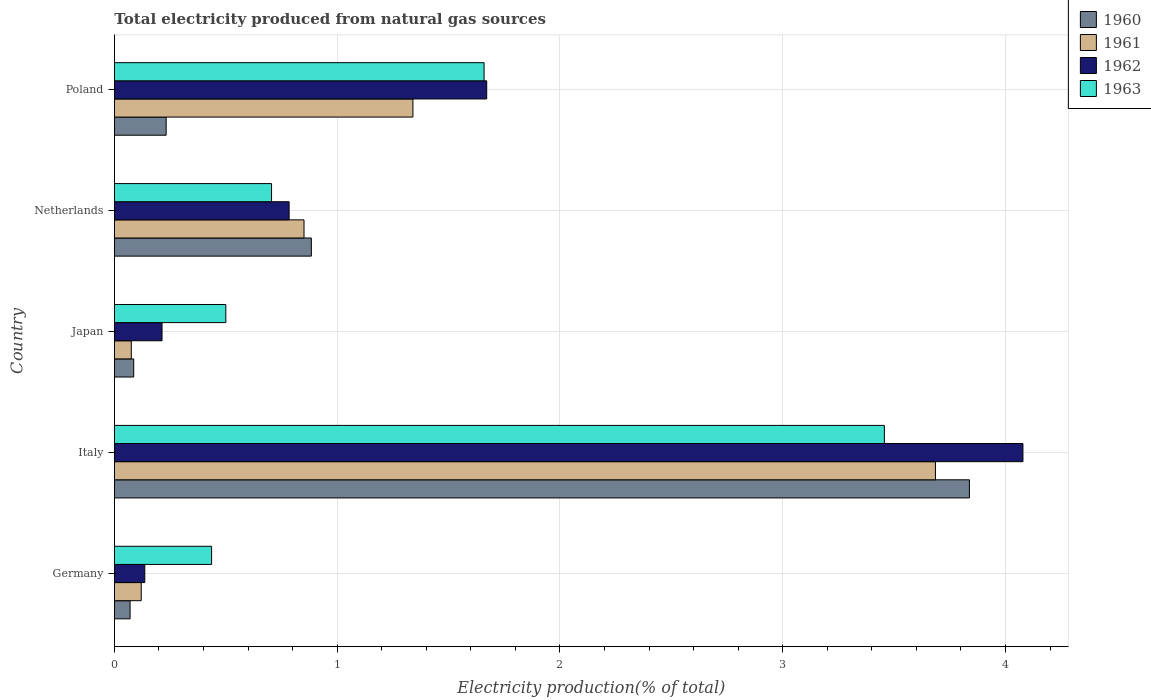How many different coloured bars are there?
Offer a very short reply. 4. Are the number of bars on each tick of the Y-axis equal?
Keep it short and to the point. Yes. How many bars are there on the 2nd tick from the bottom?
Offer a very short reply. 4. What is the label of the 2nd group of bars from the top?
Give a very brief answer. Netherlands. What is the total electricity produced in 1961 in Germany?
Your response must be concise. 0.12. Across all countries, what is the maximum total electricity produced in 1961?
Offer a very short reply. 3.69. Across all countries, what is the minimum total electricity produced in 1961?
Keep it short and to the point. 0.08. What is the total total electricity produced in 1962 in the graph?
Offer a very short reply. 6.88. What is the difference between the total electricity produced in 1960 in Germany and that in Italy?
Your answer should be very brief. -3.77. What is the difference between the total electricity produced in 1961 in Japan and the total electricity produced in 1963 in Germany?
Your answer should be very brief. -0.36. What is the average total electricity produced in 1960 per country?
Provide a short and direct response. 1.02. What is the difference between the total electricity produced in 1961 and total electricity produced in 1963 in Italy?
Your response must be concise. 0.23. What is the ratio of the total electricity produced in 1962 in Germany to that in Japan?
Offer a very short reply. 0.64. Is the difference between the total electricity produced in 1961 in Netherlands and Poland greater than the difference between the total electricity produced in 1963 in Netherlands and Poland?
Provide a succinct answer. Yes. What is the difference between the highest and the second highest total electricity produced in 1962?
Give a very brief answer. 2.41. What is the difference between the highest and the lowest total electricity produced in 1961?
Give a very brief answer. 3.61. In how many countries, is the total electricity produced in 1960 greater than the average total electricity produced in 1960 taken over all countries?
Your answer should be compact. 1. Is the sum of the total electricity produced in 1961 in Japan and Netherlands greater than the maximum total electricity produced in 1960 across all countries?
Offer a terse response. No. Is it the case that in every country, the sum of the total electricity produced in 1960 and total electricity produced in 1962 is greater than the sum of total electricity produced in 1961 and total electricity produced in 1963?
Make the answer very short. No. How many countries are there in the graph?
Your answer should be compact. 5. Does the graph contain grids?
Offer a terse response. Yes. How are the legend labels stacked?
Make the answer very short. Vertical. What is the title of the graph?
Provide a short and direct response. Total electricity produced from natural gas sources. Does "1960" appear as one of the legend labels in the graph?
Provide a short and direct response. Yes. What is the label or title of the Y-axis?
Your answer should be compact. Country. What is the Electricity production(% of total) in 1960 in Germany?
Offer a terse response. 0.07. What is the Electricity production(% of total) of 1961 in Germany?
Offer a very short reply. 0.12. What is the Electricity production(% of total) in 1962 in Germany?
Your answer should be compact. 0.14. What is the Electricity production(% of total) in 1963 in Germany?
Provide a succinct answer. 0.44. What is the Electricity production(% of total) of 1960 in Italy?
Your answer should be compact. 3.84. What is the Electricity production(% of total) in 1961 in Italy?
Provide a succinct answer. 3.69. What is the Electricity production(% of total) of 1962 in Italy?
Ensure brevity in your answer.  4.08. What is the Electricity production(% of total) in 1963 in Italy?
Your response must be concise. 3.46. What is the Electricity production(% of total) in 1960 in Japan?
Provide a succinct answer. 0.09. What is the Electricity production(% of total) of 1961 in Japan?
Offer a terse response. 0.08. What is the Electricity production(% of total) of 1962 in Japan?
Make the answer very short. 0.21. What is the Electricity production(% of total) of 1963 in Japan?
Make the answer very short. 0.5. What is the Electricity production(% of total) in 1960 in Netherlands?
Give a very brief answer. 0.88. What is the Electricity production(% of total) in 1961 in Netherlands?
Provide a short and direct response. 0.85. What is the Electricity production(% of total) in 1962 in Netherlands?
Keep it short and to the point. 0.78. What is the Electricity production(% of total) of 1963 in Netherlands?
Make the answer very short. 0.71. What is the Electricity production(% of total) in 1960 in Poland?
Provide a succinct answer. 0.23. What is the Electricity production(% of total) in 1961 in Poland?
Make the answer very short. 1.34. What is the Electricity production(% of total) in 1962 in Poland?
Keep it short and to the point. 1.67. What is the Electricity production(% of total) of 1963 in Poland?
Your answer should be compact. 1.66. Across all countries, what is the maximum Electricity production(% of total) of 1960?
Keep it short and to the point. 3.84. Across all countries, what is the maximum Electricity production(% of total) in 1961?
Provide a short and direct response. 3.69. Across all countries, what is the maximum Electricity production(% of total) of 1962?
Offer a very short reply. 4.08. Across all countries, what is the maximum Electricity production(% of total) of 1963?
Your answer should be very brief. 3.46. Across all countries, what is the minimum Electricity production(% of total) in 1960?
Make the answer very short. 0.07. Across all countries, what is the minimum Electricity production(% of total) of 1961?
Ensure brevity in your answer.  0.08. Across all countries, what is the minimum Electricity production(% of total) in 1962?
Ensure brevity in your answer.  0.14. Across all countries, what is the minimum Electricity production(% of total) of 1963?
Give a very brief answer. 0.44. What is the total Electricity production(% of total) of 1960 in the graph?
Provide a succinct answer. 5.11. What is the total Electricity production(% of total) of 1961 in the graph?
Provide a short and direct response. 6.07. What is the total Electricity production(% of total) of 1962 in the graph?
Your answer should be compact. 6.88. What is the total Electricity production(% of total) of 1963 in the graph?
Your answer should be compact. 6.76. What is the difference between the Electricity production(% of total) of 1960 in Germany and that in Italy?
Offer a terse response. -3.77. What is the difference between the Electricity production(% of total) of 1961 in Germany and that in Italy?
Provide a short and direct response. -3.57. What is the difference between the Electricity production(% of total) in 1962 in Germany and that in Italy?
Keep it short and to the point. -3.94. What is the difference between the Electricity production(% of total) of 1963 in Germany and that in Italy?
Ensure brevity in your answer.  -3.02. What is the difference between the Electricity production(% of total) of 1960 in Germany and that in Japan?
Provide a short and direct response. -0.02. What is the difference between the Electricity production(% of total) of 1961 in Germany and that in Japan?
Make the answer very short. 0.04. What is the difference between the Electricity production(% of total) in 1962 in Germany and that in Japan?
Your answer should be compact. -0.08. What is the difference between the Electricity production(% of total) of 1963 in Germany and that in Japan?
Keep it short and to the point. -0.06. What is the difference between the Electricity production(% of total) in 1960 in Germany and that in Netherlands?
Provide a short and direct response. -0.81. What is the difference between the Electricity production(% of total) in 1961 in Germany and that in Netherlands?
Your answer should be very brief. -0.73. What is the difference between the Electricity production(% of total) of 1962 in Germany and that in Netherlands?
Make the answer very short. -0.65. What is the difference between the Electricity production(% of total) of 1963 in Germany and that in Netherlands?
Offer a terse response. -0.27. What is the difference between the Electricity production(% of total) of 1960 in Germany and that in Poland?
Make the answer very short. -0.16. What is the difference between the Electricity production(% of total) of 1961 in Germany and that in Poland?
Give a very brief answer. -1.22. What is the difference between the Electricity production(% of total) in 1962 in Germany and that in Poland?
Provide a short and direct response. -1.53. What is the difference between the Electricity production(% of total) of 1963 in Germany and that in Poland?
Offer a very short reply. -1.22. What is the difference between the Electricity production(% of total) in 1960 in Italy and that in Japan?
Give a very brief answer. 3.75. What is the difference between the Electricity production(% of total) of 1961 in Italy and that in Japan?
Your answer should be compact. 3.61. What is the difference between the Electricity production(% of total) in 1962 in Italy and that in Japan?
Give a very brief answer. 3.86. What is the difference between the Electricity production(% of total) of 1963 in Italy and that in Japan?
Make the answer very short. 2.96. What is the difference between the Electricity production(% of total) in 1960 in Italy and that in Netherlands?
Offer a terse response. 2.95. What is the difference between the Electricity production(% of total) in 1961 in Italy and that in Netherlands?
Provide a succinct answer. 2.83. What is the difference between the Electricity production(% of total) in 1962 in Italy and that in Netherlands?
Offer a very short reply. 3.29. What is the difference between the Electricity production(% of total) in 1963 in Italy and that in Netherlands?
Keep it short and to the point. 2.75. What is the difference between the Electricity production(% of total) in 1960 in Italy and that in Poland?
Provide a short and direct response. 3.61. What is the difference between the Electricity production(% of total) of 1961 in Italy and that in Poland?
Ensure brevity in your answer.  2.35. What is the difference between the Electricity production(% of total) of 1962 in Italy and that in Poland?
Offer a terse response. 2.41. What is the difference between the Electricity production(% of total) in 1963 in Italy and that in Poland?
Your answer should be compact. 1.8. What is the difference between the Electricity production(% of total) in 1960 in Japan and that in Netherlands?
Your answer should be very brief. -0.8. What is the difference between the Electricity production(% of total) in 1961 in Japan and that in Netherlands?
Keep it short and to the point. -0.78. What is the difference between the Electricity production(% of total) of 1962 in Japan and that in Netherlands?
Offer a terse response. -0.57. What is the difference between the Electricity production(% of total) of 1963 in Japan and that in Netherlands?
Your response must be concise. -0.21. What is the difference between the Electricity production(% of total) in 1960 in Japan and that in Poland?
Your response must be concise. -0.15. What is the difference between the Electricity production(% of total) in 1961 in Japan and that in Poland?
Ensure brevity in your answer.  -1.26. What is the difference between the Electricity production(% of total) in 1962 in Japan and that in Poland?
Offer a very short reply. -1.46. What is the difference between the Electricity production(% of total) of 1963 in Japan and that in Poland?
Provide a short and direct response. -1.16. What is the difference between the Electricity production(% of total) in 1960 in Netherlands and that in Poland?
Make the answer very short. 0.65. What is the difference between the Electricity production(% of total) of 1961 in Netherlands and that in Poland?
Provide a short and direct response. -0.49. What is the difference between the Electricity production(% of total) of 1962 in Netherlands and that in Poland?
Offer a very short reply. -0.89. What is the difference between the Electricity production(% of total) in 1963 in Netherlands and that in Poland?
Provide a short and direct response. -0.95. What is the difference between the Electricity production(% of total) of 1960 in Germany and the Electricity production(% of total) of 1961 in Italy?
Offer a very short reply. -3.62. What is the difference between the Electricity production(% of total) in 1960 in Germany and the Electricity production(% of total) in 1962 in Italy?
Make the answer very short. -4.01. What is the difference between the Electricity production(% of total) of 1960 in Germany and the Electricity production(% of total) of 1963 in Italy?
Provide a succinct answer. -3.39. What is the difference between the Electricity production(% of total) in 1961 in Germany and the Electricity production(% of total) in 1962 in Italy?
Provide a short and direct response. -3.96. What is the difference between the Electricity production(% of total) of 1961 in Germany and the Electricity production(% of total) of 1963 in Italy?
Provide a succinct answer. -3.34. What is the difference between the Electricity production(% of total) of 1962 in Germany and the Electricity production(% of total) of 1963 in Italy?
Ensure brevity in your answer.  -3.32. What is the difference between the Electricity production(% of total) in 1960 in Germany and the Electricity production(% of total) in 1961 in Japan?
Keep it short and to the point. -0.01. What is the difference between the Electricity production(% of total) of 1960 in Germany and the Electricity production(% of total) of 1962 in Japan?
Your answer should be very brief. -0.14. What is the difference between the Electricity production(% of total) of 1960 in Germany and the Electricity production(% of total) of 1963 in Japan?
Offer a very short reply. -0.43. What is the difference between the Electricity production(% of total) of 1961 in Germany and the Electricity production(% of total) of 1962 in Japan?
Provide a short and direct response. -0.09. What is the difference between the Electricity production(% of total) in 1961 in Germany and the Electricity production(% of total) in 1963 in Japan?
Keep it short and to the point. -0.38. What is the difference between the Electricity production(% of total) in 1962 in Germany and the Electricity production(% of total) in 1963 in Japan?
Your answer should be very brief. -0.36. What is the difference between the Electricity production(% of total) of 1960 in Germany and the Electricity production(% of total) of 1961 in Netherlands?
Your answer should be very brief. -0.78. What is the difference between the Electricity production(% of total) of 1960 in Germany and the Electricity production(% of total) of 1962 in Netherlands?
Provide a succinct answer. -0.71. What is the difference between the Electricity production(% of total) of 1960 in Germany and the Electricity production(% of total) of 1963 in Netherlands?
Offer a very short reply. -0.64. What is the difference between the Electricity production(% of total) of 1961 in Germany and the Electricity production(% of total) of 1962 in Netherlands?
Your answer should be very brief. -0.66. What is the difference between the Electricity production(% of total) of 1961 in Germany and the Electricity production(% of total) of 1963 in Netherlands?
Ensure brevity in your answer.  -0.58. What is the difference between the Electricity production(% of total) of 1962 in Germany and the Electricity production(% of total) of 1963 in Netherlands?
Provide a succinct answer. -0.57. What is the difference between the Electricity production(% of total) in 1960 in Germany and the Electricity production(% of total) in 1961 in Poland?
Make the answer very short. -1.27. What is the difference between the Electricity production(% of total) in 1960 in Germany and the Electricity production(% of total) in 1962 in Poland?
Your answer should be compact. -1.6. What is the difference between the Electricity production(% of total) in 1960 in Germany and the Electricity production(% of total) in 1963 in Poland?
Ensure brevity in your answer.  -1.59. What is the difference between the Electricity production(% of total) of 1961 in Germany and the Electricity production(% of total) of 1962 in Poland?
Offer a terse response. -1.55. What is the difference between the Electricity production(% of total) of 1961 in Germany and the Electricity production(% of total) of 1963 in Poland?
Your answer should be very brief. -1.54. What is the difference between the Electricity production(% of total) of 1962 in Germany and the Electricity production(% of total) of 1963 in Poland?
Your response must be concise. -1.52. What is the difference between the Electricity production(% of total) of 1960 in Italy and the Electricity production(% of total) of 1961 in Japan?
Your answer should be very brief. 3.76. What is the difference between the Electricity production(% of total) of 1960 in Italy and the Electricity production(% of total) of 1962 in Japan?
Your response must be concise. 3.62. What is the difference between the Electricity production(% of total) in 1960 in Italy and the Electricity production(% of total) in 1963 in Japan?
Your answer should be very brief. 3.34. What is the difference between the Electricity production(% of total) of 1961 in Italy and the Electricity production(% of total) of 1962 in Japan?
Your answer should be very brief. 3.47. What is the difference between the Electricity production(% of total) of 1961 in Italy and the Electricity production(% of total) of 1963 in Japan?
Offer a terse response. 3.19. What is the difference between the Electricity production(% of total) in 1962 in Italy and the Electricity production(% of total) in 1963 in Japan?
Your answer should be compact. 3.58. What is the difference between the Electricity production(% of total) of 1960 in Italy and the Electricity production(% of total) of 1961 in Netherlands?
Your response must be concise. 2.99. What is the difference between the Electricity production(% of total) in 1960 in Italy and the Electricity production(% of total) in 1962 in Netherlands?
Your response must be concise. 3.05. What is the difference between the Electricity production(% of total) of 1960 in Italy and the Electricity production(% of total) of 1963 in Netherlands?
Your response must be concise. 3.13. What is the difference between the Electricity production(% of total) in 1961 in Italy and the Electricity production(% of total) in 1962 in Netherlands?
Your answer should be compact. 2.9. What is the difference between the Electricity production(% of total) of 1961 in Italy and the Electricity production(% of total) of 1963 in Netherlands?
Provide a succinct answer. 2.98. What is the difference between the Electricity production(% of total) of 1962 in Italy and the Electricity production(% of total) of 1963 in Netherlands?
Give a very brief answer. 3.37. What is the difference between the Electricity production(% of total) in 1960 in Italy and the Electricity production(% of total) in 1961 in Poland?
Your answer should be very brief. 2.5. What is the difference between the Electricity production(% of total) of 1960 in Italy and the Electricity production(% of total) of 1962 in Poland?
Provide a succinct answer. 2.17. What is the difference between the Electricity production(% of total) in 1960 in Italy and the Electricity production(% of total) in 1963 in Poland?
Offer a terse response. 2.18. What is the difference between the Electricity production(% of total) of 1961 in Italy and the Electricity production(% of total) of 1962 in Poland?
Offer a terse response. 2.01. What is the difference between the Electricity production(% of total) in 1961 in Italy and the Electricity production(% of total) in 1963 in Poland?
Offer a terse response. 2.03. What is the difference between the Electricity production(% of total) in 1962 in Italy and the Electricity production(% of total) in 1963 in Poland?
Provide a succinct answer. 2.42. What is the difference between the Electricity production(% of total) of 1960 in Japan and the Electricity production(% of total) of 1961 in Netherlands?
Your response must be concise. -0.76. What is the difference between the Electricity production(% of total) in 1960 in Japan and the Electricity production(% of total) in 1962 in Netherlands?
Make the answer very short. -0.7. What is the difference between the Electricity production(% of total) of 1960 in Japan and the Electricity production(% of total) of 1963 in Netherlands?
Make the answer very short. -0.62. What is the difference between the Electricity production(% of total) of 1961 in Japan and the Electricity production(% of total) of 1962 in Netherlands?
Your answer should be compact. -0.71. What is the difference between the Electricity production(% of total) in 1961 in Japan and the Electricity production(% of total) in 1963 in Netherlands?
Offer a terse response. -0.63. What is the difference between the Electricity production(% of total) in 1962 in Japan and the Electricity production(% of total) in 1963 in Netherlands?
Your answer should be compact. -0.49. What is the difference between the Electricity production(% of total) in 1960 in Japan and the Electricity production(% of total) in 1961 in Poland?
Provide a succinct answer. -1.25. What is the difference between the Electricity production(% of total) in 1960 in Japan and the Electricity production(% of total) in 1962 in Poland?
Ensure brevity in your answer.  -1.58. What is the difference between the Electricity production(% of total) in 1960 in Japan and the Electricity production(% of total) in 1963 in Poland?
Make the answer very short. -1.57. What is the difference between the Electricity production(% of total) in 1961 in Japan and the Electricity production(% of total) in 1962 in Poland?
Make the answer very short. -1.6. What is the difference between the Electricity production(% of total) in 1961 in Japan and the Electricity production(% of total) in 1963 in Poland?
Provide a short and direct response. -1.58. What is the difference between the Electricity production(% of total) in 1962 in Japan and the Electricity production(% of total) in 1963 in Poland?
Offer a terse response. -1.45. What is the difference between the Electricity production(% of total) in 1960 in Netherlands and the Electricity production(% of total) in 1961 in Poland?
Provide a short and direct response. -0.46. What is the difference between the Electricity production(% of total) of 1960 in Netherlands and the Electricity production(% of total) of 1962 in Poland?
Your answer should be compact. -0.79. What is the difference between the Electricity production(% of total) of 1960 in Netherlands and the Electricity production(% of total) of 1963 in Poland?
Offer a terse response. -0.78. What is the difference between the Electricity production(% of total) in 1961 in Netherlands and the Electricity production(% of total) in 1962 in Poland?
Give a very brief answer. -0.82. What is the difference between the Electricity production(% of total) of 1961 in Netherlands and the Electricity production(% of total) of 1963 in Poland?
Make the answer very short. -0.81. What is the difference between the Electricity production(% of total) of 1962 in Netherlands and the Electricity production(% of total) of 1963 in Poland?
Your response must be concise. -0.88. What is the average Electricity production(% of total) in 1960 per country?
Provide a short and direct response. 1.02. What is the average Electricity production(% of total) in 1961 per country?
Provide a short and direct response. 1.21. What is the average Electricity production(% of total) in 1962 per country?
Your answer should be compact. 1.38. What is the average Electricity production(% of total) in 1963 per country?
Make the answer very short. 1.35. What is the difference between the Electricity production(% of total) of 1960 and Electricity production(% of total) of 1961 in Germany?
Give a very brief answer. -0.05. What is the difference between the Electricity production(% of total) in 1960 and Electricity production(% of total) in 1962 in Germany?
Keep it short and to the point. -0.07. What is the difference between the Electricity production(% of total) in 1960 and Electricity production(% of total) in 1963 in Germany?
Provide a succinct answer. -0.37. What is the difference between the Electricity production(% of total) in 1961 and Electricity production(% of total) in 1962 in Germany?
Ensure brevity in your answer.  -0.02. What is the difference between the Electricity production(% of total) of 1961 and Electricity production(% of total) of 1963 in Germany?
Your answer should be very brief. -0.32. What is the difference between the Electricity production(% of total) of 1962 and Electricity production(% of total) of 1963 in Germany?
Offer a terse response. -0.3. What is the difference between the Electricity production(% of total) of 1960 and Electricity production(% of total) of 1961 in Italy?
Your answer should be very brief. 0.15. What is the difference between the Electricity production(% of total) in 1960 and Electricity production(% of total) in 1962 in Italy?
Your answer should be very brief. -0.24. What is the difference between the Electricity production(% of total) in 1960 and Electricity production(% of total) in 1963 in Italy?
Provide a short and direct response. 0.38. What is the difference between the Electricity production(% of total) in 1961 and Electricity production(% of total) in 1962 in Italy?
Your response must be concise. -0.39. What is the difference between the Electricity production(% of total) of 1961 and Electricity production(% of total) of 1963 in Italy?
Ensure brevity in your answer.  0.23. What is the difference between the Electricity production(% of total) in 1962 and Electricity production(% of total) in 1963 in Italy?
Provide a short and direct response. 0.62. What is the difference between the Electricity production(% of total) of 1960 and Electricity production(% of total) of 1961 in Japan?
Make the answer very short. 0.01. What is the difference between the Electricity production(% of total) in 1960 and Electricity production(% of total) in 1962 in Japan?
Keep it short and to the point. -0.13. What is the difference between the Electricity production(% of total) in 1960 and Electricity production(% of total) in 1963 in Japan?
Your answer should be compact. -0.41. What is the difference between the Electricity production(% of total) in 1961 and Electricity production(% of total) in 1962 in Japan?
Provide a succinct answer. -0.14. What is the difference between the Electricity production(% of total) in 1961 and Electricity production(% of total) in 1963 in Japan?
Ensure brevity in your answer.  -0.42. What is the difference between the Electricity production(% of total) in 1962 and Electricity production(% of total) in 1963 in Japan?
Offer a terse response. -0.29. What is the difference between the Electricity production(% of total) in 1960 and Electricity production(% of total) in 1961 in Netherlands?
Give a very brief answer. 0.03. What is the difference between the Electricity production(% of total) in 1960 and Electricity production(% of total) in 1962 in Netherlands?
Provide a succinct answer. 0.1. What is the difference between the Electricity production(% of total) in 1960 and Electricity production(% of total) in 1963 in Netherlands?
Your answer should be compact. 0.18. What is the difference between the Electricity production(% of total) of 1961 and Electricity production(% of total) of 1962 in Netherlands?
Provide a short and direct response. 0.07. What is the difference between the Electricity production(% of total) of 1961 and Electricity production(% of total) of 1963 in Netherlands?
Offer a very short reply. 0.15. What is the difference between the Electricity production(% of total) of 1962 and Electricity production(% of total) of 1963 in Netherlands?
Keep it short and to the point. 0.08. What is the difference between the Electricity production(% of total) of 1960 and Electricity production(% of total) of 1961 in Poland?
Give a very brief answer. -1.11. What is the difference between the Electricity production(% of total) in 1960 and Electricity production(% of total) in 1962 in Poland?
Your answer should be very brief. -1.44. What is the difference between the Electricity production(% of total) of 1960 and Electricity production(% of total) of 1963 in Poland?
Provide a succinct answer. -1.43. What is the difference between the Electricity production(% of total) of 1961 and Electricity production(% of total) of 1962 in Poland?
Give a very brief answer. -0.33. What is the difference between the Electricity production(% of total) in 1961 and Electricity production(% of total) in 1963 in Poland?
Keep it short and to the point. -0.32. What is the difference between the Electricity production(% of total) of 1962 and Electricity production(% of total) of 1963 in Poland?
Ensure brevity in your answer.  0.01. What is the ratio of the Electricity production(% of total) in 1960 in Germany to that in Italy?
Keep it short and to the point. 0.02. What is the ratio of the Electricity production(% of total) of 1961 in Germany to that in Italy?
Make the answer very short. 0.03. What is the ratio of the Electricity production(% of total) of 1962 in Germany to that in Italy?
Your response must be concise. 0.03. What is the ratio of the Electricity production(% of total) in 1963 in Germany to that in Italy?
Offer a terse response. 0.13. What is the ratio of the Electricity production(% of total) in 1960 in Germany to that in Japan?
Your response must be concise. 0.81. What is the ratio of the Electricity production(% of total) in 1961 in Germany to that in Japan?
Provide a succinct answer. 1.59. What is the ratio of the Electricity production(% of total) in 1962 in Germany to that in Japan?
Your answer should be compact. 0.64. What is the ratio of the Electricity production(% of total) in 1963 in Germany to that in Japan?
Keep it short and to the point. 0.87. What is the ratio of the Electricity production(% of total) in 1960 in Germany to that in Netherlands?
Your answer should be very brief. 0.08. What is the ratio of the Electricity production(% of total) in 1961 in Germany to that in Netherlands?
Your answer should be very brief. 0.14. What is the ratio of the Electricity production(% of total) of 1962 in Germany to that in Netherlands?
Offer a terse response. 0.17. What is the ratio of the Electricity production(% of total) of 1963 in Germany to that in Netherlands?
Offer a very short reply. 0.62. What is the ratio of the Electricity production(% of total) in 1960 in Germany to that in Poland?
Keep it short and to the point. 0.3. What is the ratio of the Electricity production(% of total) of 1961 in Germany to that in Poland?
Give a very brief answer. 0.09. What is the ratio of the Electricity production(% of total) of 1962 in Germany to that in Poland?
Provide a succinct answer. 0.08. What is the ratio of the Electricity production(% of total) in 1963 in Germany to that in Poland?
Offer a very short reply. 0.26. What is the ratio of the Electricity production(% of total) of 1960 in Italy to that in Japan?
Give a very brief answer. 44.33. What is the ratio of the Electricity production(% of total) of 1961 in Italy to that in Japan?
Provide a short and direct response. 48.69. What is the ratio of the Electricity production(% of total) of 1962 in Italy to that in Japan?
Your response must be concise. 19.09. What is the ratio of the Electricity production(% of total) in 1963 in Italy to that in Japan?
Make the answer very short. 6.91. What is the ratio of the Electricity production(% of total) of 1960 in Italy to that in Netherlands?
Your response must be concise. 4.34. What is the ratio of the Electricity production(% of total) in 1961 in Italy to that in Netherlands?
Give a very brief answer. 4.33. What is the ratio of the Electricity production(% of total) in 1962 in Italy to that in Netherlands?
Make the answer very short. 5.2. What is the ratio of the Electricity production(% of total) in 1963 in Italy to that in Netherlands?
Keep it short and to the point. 4.9. What is the ratio of the Electricity production(% of total) of 1960 in Italy to that in Poland?
Make the answer very short. 16.53. What is the ratio of the Electricity production(% of total) in 1961 in Italy to that in Poland?
Your answer should be compact. 2.75. What is the ratio of the Electricity production(% of total) in 1962 in Italy to that in Poland?
Keep it short and to the point. 2.44. What is the ratio of the Electricity production(% of total) in 1963 in Italy to that in Poland?
Offer a very short reply. 2.08. What is the ratio of the Electricity production(% of total) of 1960 in Japan to that in Netherlands?
Ensure brevity in your answer.  0.1. What is the ratio of the Electricity production(% of total) in 1961 in Japan to that in Netherlands?
Give a very brief answer. 0.09. What is the ratio of the Electricity production(% of total) in 1962 in Japan to that in Netherlands?
Make the answer very short. 0.27. What is the ratio of the Electricity production(% of total) in 1963 in Japan to that in Netherlands?
Your response must be concise. 0.71. What is the ratio of the Electricity production(% of total) in 1960 in Japan to that in Poland?
Your answer should be compact. 0.37. What is the ratio of the Electricity production(% of total) of 1961 in Japan to that in Poland?
Provide a short and direct response. 0.06. What is the ratio of the Electricity production(% of total) in 1962 in Japan to that in Poland?
Your response must be concise. 0.13. What is the ratio of the Electricity production(% of total) in 1963 in Japan to that in Poland?
Offer a very short reply. 0.3. What is the ratio of the Electricity production(% of total) in 1960 in Netherlands to that in Poland?
Provide a succinct answer. 3.81. What is the ratio of the Electricity production(% of total) of 1961 in Netherlands to that in Poland?
Keep it short and to the point. 0.64. What is the ratio of the Electricity production(% of total) in 1962 in Netherlands to that in Poland?
Your answer should be compact. 0.47. What is the ratio of the Electricity production(% of total) in 1963 in Netherlands to that in Poland?
Offer a terse response. 0.42. What is the difference between the highest and the second highest Electricity production(% of total) in 1960?
Keep it short and to the point. 2.95. What is the difference between the highest and the second highest Electricity production(% of total) in 1961?
Provide a short and direct response. 2.35. What is the difference between the highest and the second highest Electricity production(% of total) in 1962?
Your answer should be very brief. 2.41. What is the difference between the highest and the second highest Electricity production(% of total) of 1963?
Your response must be concise. 1.8. What is the difference between the highest and the lowest Electricity production(% of total) in 1960?
Provide a succinct answer. 3.77. What is the difference between the highest and the lowest Electricity production(% of total) in 1961?
Your answer should be compact. 3.61. What is the difference between the highest and the lowest Electricity production(% of total) of 1962?
Your answer should be very brief. 3.94. What is the difference between the highest and the lowest Electricity production(% of total) of 1963?
Make the answer very short. 3.02. 